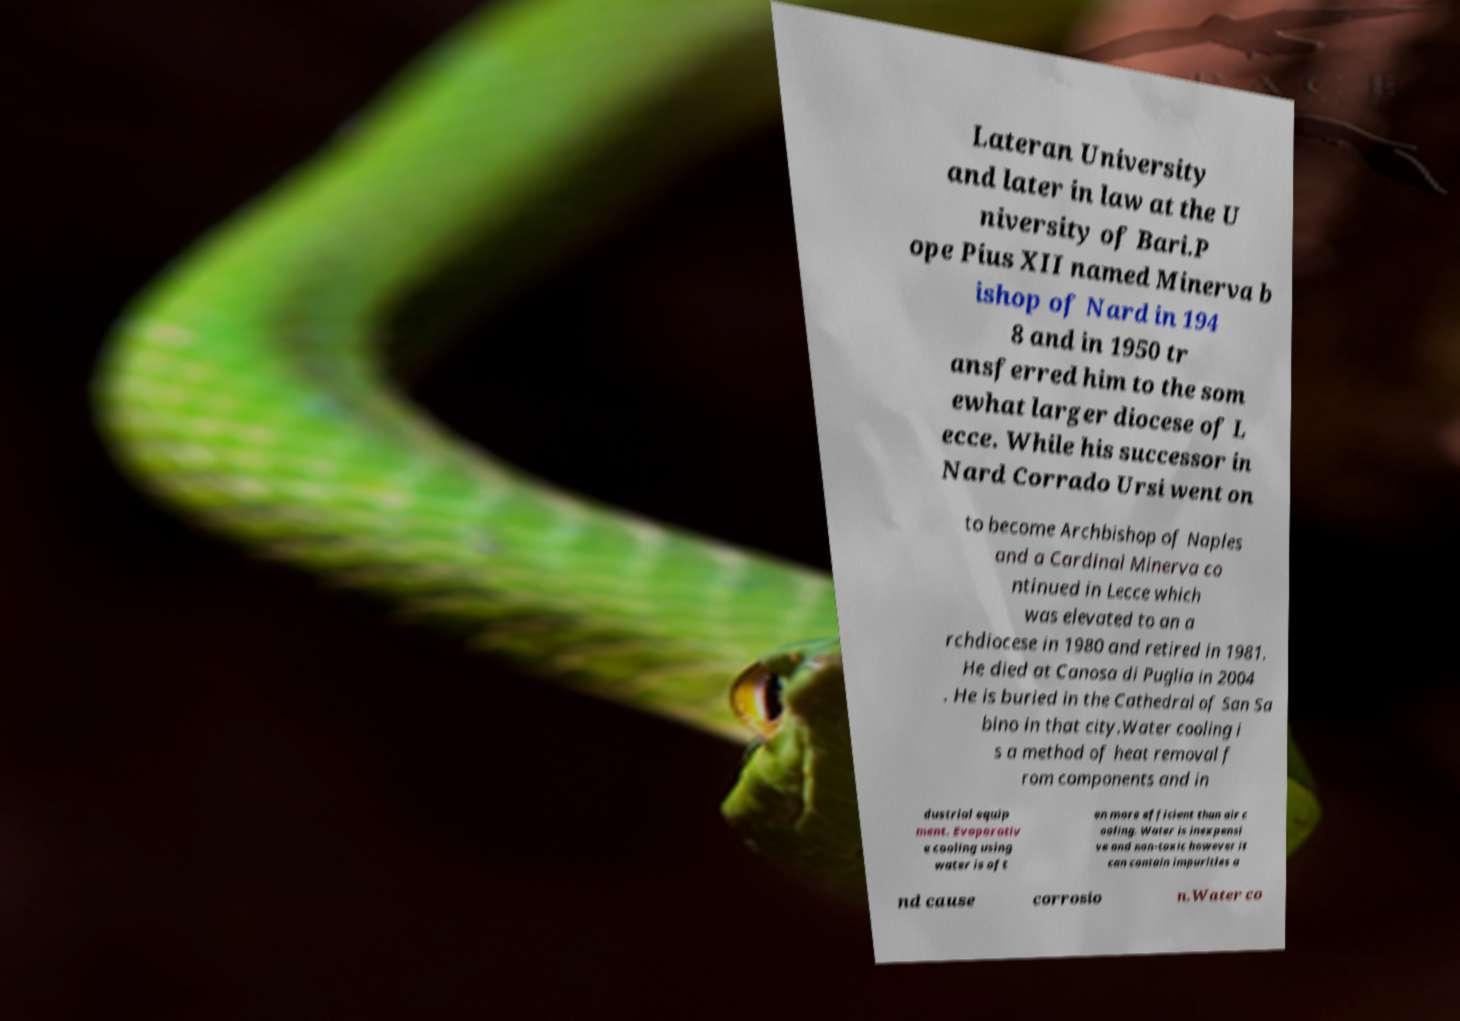Please identify and transcribe the text found in this image. Lateran University and later in law at the U niversity of Bari.P ope Pius XII named Minerva b ishop of Nard in 194 8 and in 1950 tr ansferred him to the som ewhat larger diocese of L ecce. While his successor in Nard Corrado Ursi went on to become Archbishop of Naples and a Cardinal Minerva co ntinued in Lecce which was elevated to an a rchdiocese in 1980 and retired in 1981. He died at Canosa di Puglia in 2004 . He is buried in the Cathedral of San Sa bino in that city.Water cooling i s a method of heat removal f rom components and in dustrial equip ment. Evaporativ e cooling using water is oft en more efficient than air c ooling. Water is inexpensi ve and non-toxic however it can contain impurities a nd cause corrosio n.Water co 